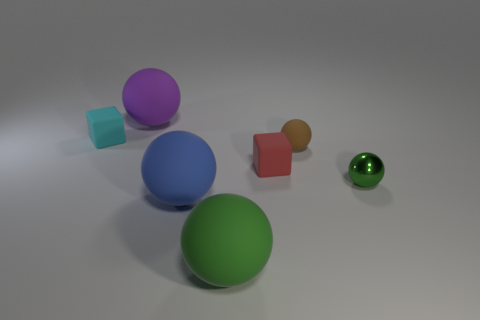Subtract all blue spheres. How many spheres are left? 4 Subtract all large purple balls. How many balls are left? 4 Subtract all brown spheres. Subtract all brown cylinders. How many spheres are left? 4 Add 2 big brown blocks. How many objects exist? 9 Subtract all cubes. How many objects are left? 5 Add 2 purple objects. How many purple objects are left? 3 Add 4 purple rubber things. How many purple rubber things exist? 5 Subtract 0 gray cylinders. How many objects are left? 7 Subtract all purple shiny spheres. Subtract all red rubber objects. How many objects are left? 6 